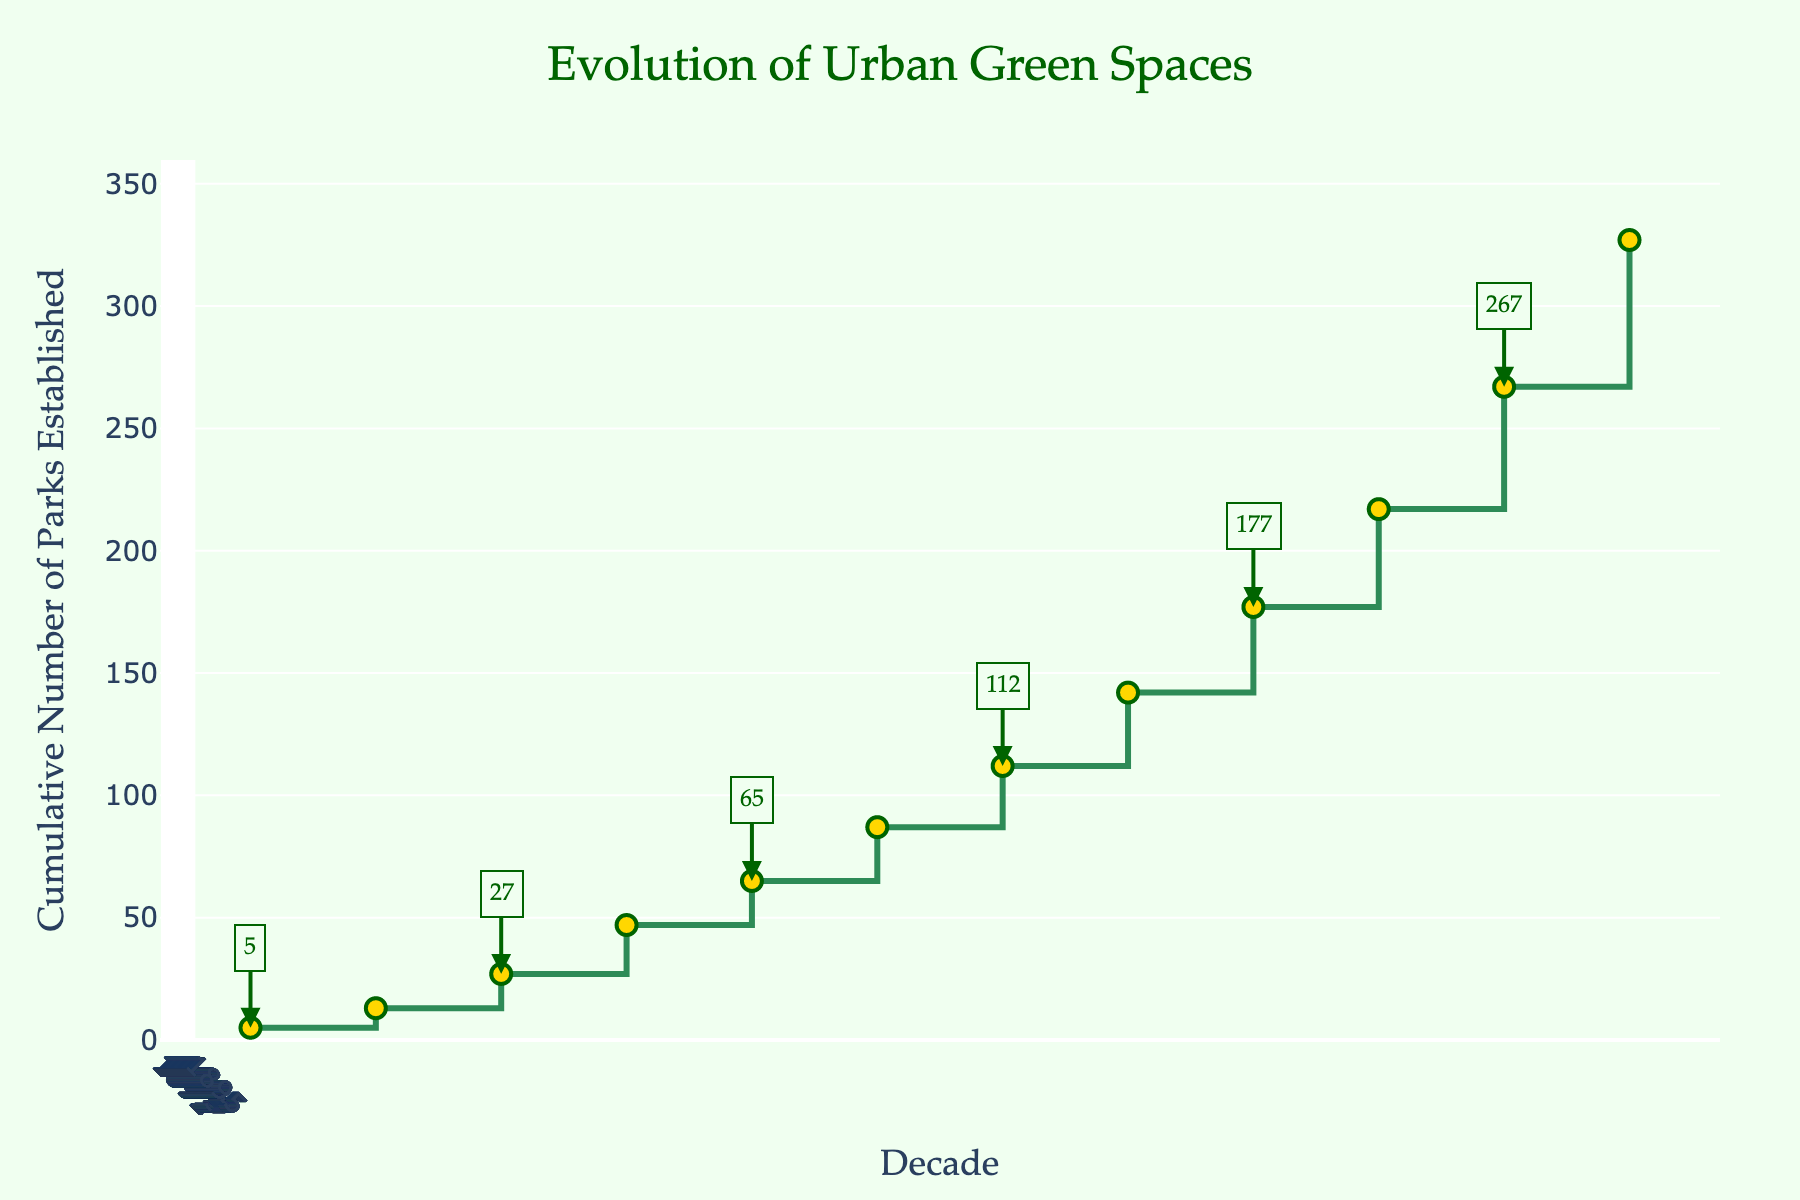What is the title of the plot? The title of the plot is prominently displayed at the top of the figure and reads 'Evolution of Urban Green Spaces'.
Answer: Evolution of Urban Green Spaces How many data points are there in total? Each data point represents a decade from 1900-1909 to 2010-2019. Counting each point, there are 12 data points in total.
Answer: 12 By how many parks did the cumulative number increase from 1940-1949 to 1950-1959? In 1940-1949, the cumulative number was 65 (5+8+14+20+18). In 1950-1959, it was 87 (65+22). The increase is 87 - 65 = 22.
Answer: 22 Which decade saw the largest increase in the cumulative number of parks established? The decade 2010-2019 shows the largest increase in the cumulative y-values, going from 110 in 2000-2009 to 170 in 2010-2019. This is an increase of 60 parks.
Answer: 2010-2019 What is the overall trend of the cumulative number of parks established over time? The overall trend shows a consistent increase in the cumulative number of parks established over the decades, indicating a steady growth in urban green spaces.
Answer: Increase How many parks were established in total by the end of 1940-1949? Summing up the number of parks established each decade until 1940-1949 gives 5+8+14+20+18, which totals to 65 parks.
Answer: 65 Which decade first saw the cumulative number of parks exceed 50? By referring to the y-values annotated on the plot, this occurred in the decade 1940-1949, totaling 65 parks by then.
Answer: 1940-1949 What is the cumulative number of parks established by the end of the 1970-1979 decade? Adding up the number of parks from 1900-1909 to 1970-1979: 5+8+14+20+18+22+25+30 results in 142 parks.
Answer: 142 Compare the cumulative growth rate of parks established from 1920-1929 to 1930-1939 with the decade 2000-2009 to 2010-2019. From 1920-1929 to 1930-1939, the cumulative number increased from 27 to 47 (47-27=20). From 2000-2009 to 2010-2019, it increased from 110 to 170 (170-110=60). Thus, the growth rate of the latter is substantially higher.
Answer: 2010-2019 Which decades have annotations displayed? Reviewing the plot, annotations are added for every other point, which means they appear for the decades 1900-1909, 1920-1929, 1940-1949, 1960-1969, 1980-1989, and 2000-2009.
Answer: 1900-1909, 1920-1929, 1940-1949, 1960-1969, 1980-1989, 2000-2009 